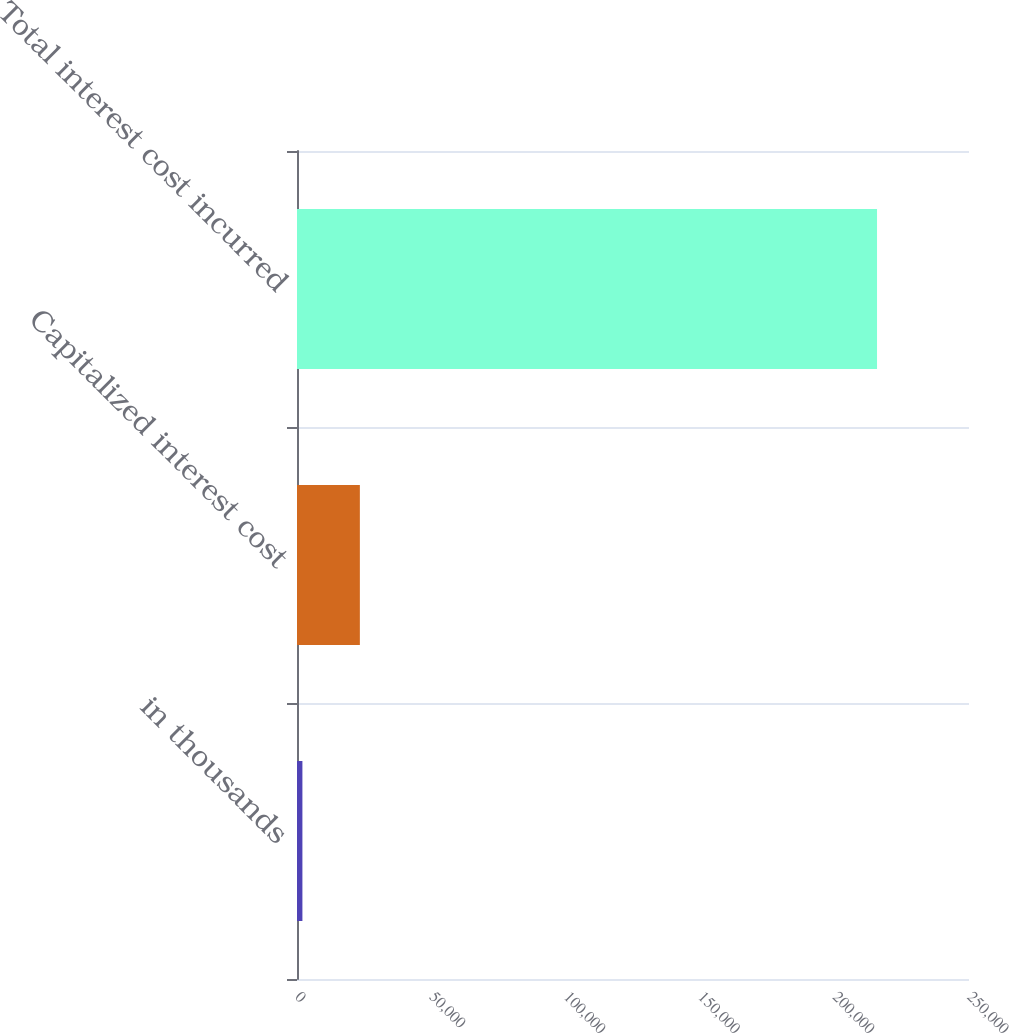Convert chart to OTSL. <chart><loc_0><loc_0><loc_500><loc_500><bar_chart><fcel>in thousands<fcel>Capitalized interest cost<fcel>Total interest cost incurred<nl><fcel>2012<fcel>23389.1<fcel>215783<nl></chart> 